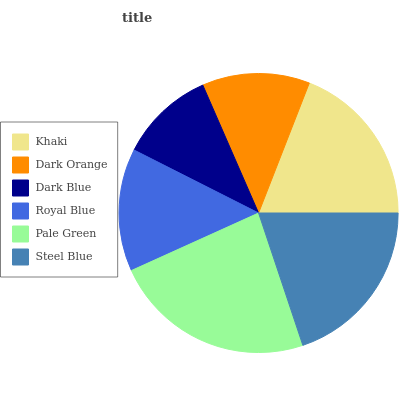Is Dark Blue the minimum?
Answer yes or no. Yes. Is Pale Green the maximum?
Answer yes or no. Yes. Is Dark Orange the minimum?
Answer yes or no. No. Is Dark Orange the maximum?
Answer yes or no. No. Is Khaki greater than Dark Orange?
Answer yes or no. Yes. Is Dark Orange less than Khaki?
Answer yes or no. Yes. Is Dark Orange greater than Khaki?
Answer yes or no. No. Is Khaki less than Dark Orange?
Answer yes or no. No. Is Khaki the high median?
Answer yes or no. Yes. Is Royal Blue the low median?
Answer yes or no. Yes. Is Dark Blue the high median?
Answer yes or no. No. Is Dark Orange the low median?
Answer yes or no. No. 